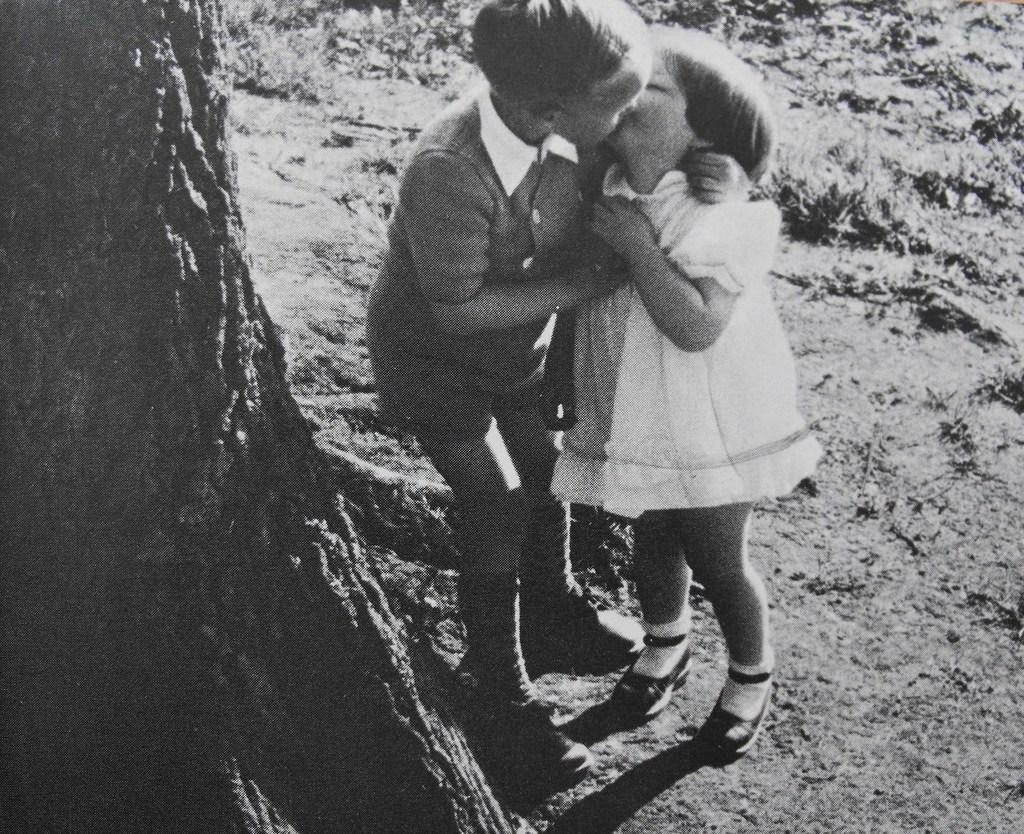How many children are in the image? There are two children in the image. What are the children wearing? The children are wearing dresses. What object can be seen in the image besides the children? There is a trunk visible in the image. What is the color scheme of the image? The image is black and white. How many spiders are crawling on the children in the image? There are no spiders visible in the image; the children are wearing dresses and standing near a trunk. What type of list is being referenced in the image? There is no list present in the image; it features two children wearing dresses and a trunk. 